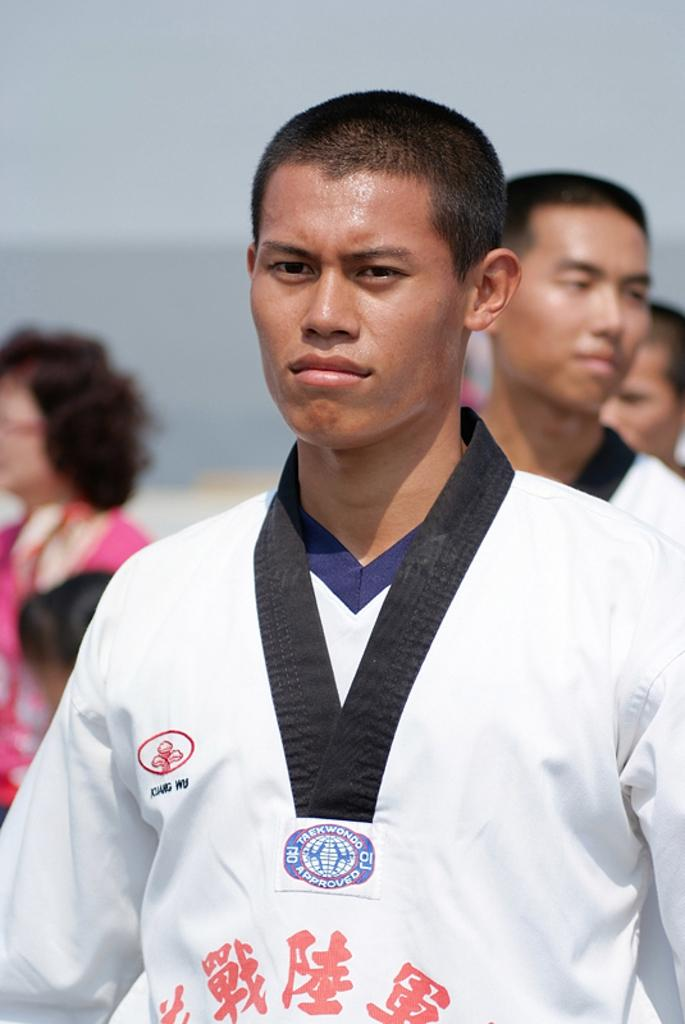What type of clothing is visible in the image? There is a white dress in the image. Can you describe the people in the image? There are people in the image, but their specific features or actions are not mentioned in the provided facts. What can be said about the background of the image? The background of the image is blurry. How many legs are visible in the image? The provided facts do not mention any legs or specific body parts of the people in the image, so it is impossible to answer this question definitively. 